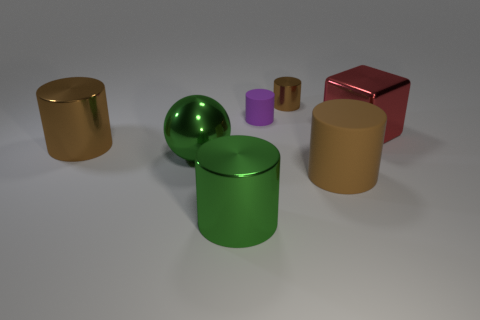Is the material of the red block the same as the sphere?
Your answer should be compact. Yes. There is another tiny thing that is the same shape as the tiny purple thing; what is its color?
Offer a very short reply. Brown. What shape is the thing that is the same color as the metallic ball?
Your answer should be compact. Cylinder. The cylinder that is the same size as the purple rubber thing is what color?
Make the answer very short. Brown. The shiny cylinder that is the same color as the large metallic ball is what size?
Your answer should be very brief. Large. Is the large brown thing behind the green sphere made of the same material as the purple object?
Offer a very short reply. No. What number of brown cylinders are both behind the large block and to the right of the small brown shiny cylinder?
Your answer should be compact. 0. What is the color of the object that is to the right of the brown cylinder right of the brown shiny cylinder behind the purple rubber thing?
Give a very brief answer. Red. How many other things are the same shape as the small purple object?
Your response must be concise. 4. Is there a green metal sphere behind the rubber cylinder that is to the left of the big rubber cylinder?
Offer a very short reply. No. 